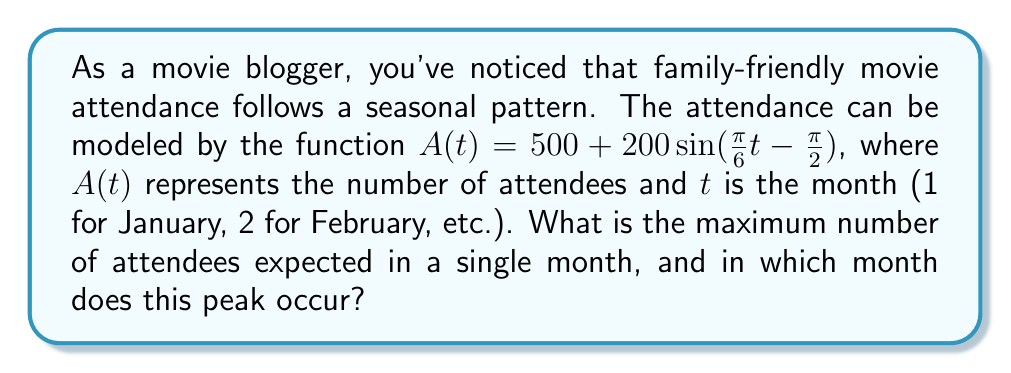Teach me how to tackle this problem. To solve this problem, let's follow these steps:

1) The given function is in the form of a sine wave:
   $A(t) = 500 + 200\sin(\frac{\pi}{6}t - \frac{\pi}{2})$

2) In a sine function $a\sin(bt + c) + d$:
   - $d$ is the midline (average value)
   - $a$ is the amplitude (half the distance between max and min)
   - $b$ affects the period
   - $c$ is the phase shift

3) In our function:
   - Midline is 500
   - Amplitude is 200

4) The maximum value of a sine function occurs when $\sin(\theta) = 1$
   So, the maximum attendance is: $500 + 200 = 700$

5) To find when this maximum occurs, we need to solve:
   $\frac{\pi}{6}t - \frac{\pi}{2} = \frac{\pi}{2}$ (because $\sin(\frac{\pi}{2}) = 1$)

6) Solving for $t$:
   $\frac{\pi}{6}t = \pi$
   $t = 6$

7) $t = 6$ corresponds to June

Therefore, the maximum attendance of 700 occurs in June.
Answer: 700 attendees in June 